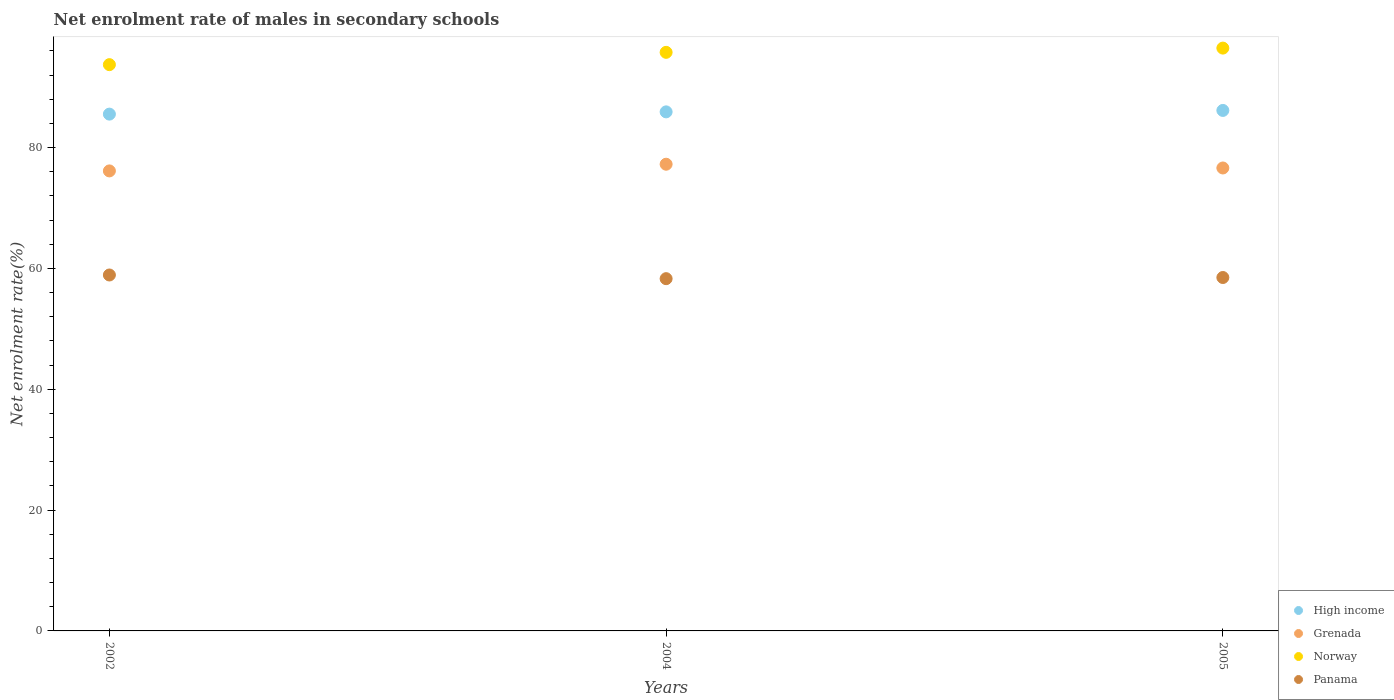How many different coloured dotlines are there?
Your response must be concise. 4. What is the net enrolment rate of males in secondary schools in Grenada in 2002?
Give a very brief answer. 76.14. Across all years, what is the maximum net enrolment rate of males in secondary schools in High income?
Your answer should be very brief. 86.15. Across all years, what is the minimum net enrolment rate of males in secondary schools in High income?
Make the answer very short. 85.54. In which year was the net enrolment rate of males in secondary schools in Panama minimum?
Provide a short and direct response. 2004. What is the total net enrolment rate of males in secondary schools in Grenada in the graph?
Give a very brief answer. 230. What is the difference between the net enrolment rate of males in secondary schools in Panama in 2002 and that in 2005?
Your response must be concise. 0.42. What is the difference between the net enrolment rate of males in secondary schools in Panama in 2002 and the net enrolment rate of males in secondary schools in Grenada in 2005?
Ensure brevity in your answer.  -17.71. What is the average net enrolment rate of males in secondary schools in High income per year?
Offer a very short reply. 85.86. In the year 2004, what is the difference between the net enrolment rate of males in secondary schools in Panama and net enrolment rate of males in secondary schools in High income?
Offer a terse response. -27.61. In how many years, is the net enrolment rate of males in secondary schools in Panama greater than 56 %?
Provide a short and direct response. 3. What is the ratio of the net enrolment rate of males in secondary schools in Norway in 2004 to that in 2005?
Offer a very short reply. 0.99. Is the net enrolment rate of males in secondary schools in Norway in 2002 less than that in 2005?
Provide a succinct answer. Yes. Is the difference between the net enrolment rate of males in secondary schools in Panama in 2004 and 2005 greater than the difference between the net enrolment rate of males in secondary schools in High income in 2004 and 2005?
Ensure brevity in your answer.  Yes. What is the difference between the highest and the second highest net enrolment rate of males in secondary schools in Grenada?
Your answer should be very brief. 0.62. What is the difference between the highest and the lowest net enrolment rate of males in secondary schools in Panama?
Your response must be concise. 0.61. In how many years, is the net enrolment rate of males in secondary schools in High income greater than the average net enrolment rate of males in secondary schools in High income taken over all years?
Make the answer very short. 2. Is it the case that in every year, the sum of the net enrolment rate of males in secondary schools in Panama and net enrolment rate of males in secondary schools in Grenada  is greater than the net enrolment rate of males in secondary schools in Norway?
Your response must be concise. Yes. Does the graph contain any zero values?
Provide a short and direct response. No. Where does the legend appear in the graph?
Keep it short and to the point. Bottom right. How many legend labels are there?
Your response must be concise. 4. What is the title of the graph?
Give a very brief answer. Net enrolment rate of males in secondary schools. Does "Arab World" appear as one of the legend labels in the graph?
Your answer should be very brief. No. What is the label or title of the X-axis?
Your answer should be very brief. Years. What is the label or title of the Y-axis?
Give a very brief answer. Net enrolment rate(%). What is the Net enrolment rate(%) of High income in 2002?
Ensure brevity in your answer.  85.54. What is the Net enrolment rate(%) of Grenada in 2002?
Your answer should be very brief. 76.14. What is the Net enrolment rate(%) of Norway in 2002?
Provide a short and direct response. 93.72. What is the Net enrolment rate(%) of Panama in 2002?
Your answer should be compact. 58.91. What is the Net enrolment rate(%) of High income in 2004?
Your answer should be compact. 85.91. What is the Net enrolment rate(%) in Grenada in 2004?
Make the answer very short. 77.24. What is the Net enrolment rate(%) of Norway in 2004?
Provide a succinct answer. 95.76. What is the Net enrolment rate(%) of Panama in 2004?
Your response must be concise. 58.3. What is the Net enrolment rate(%) of High income in 2005?
Your answer should be compact. 86.15. What is the Net enrolment rate(%) in Grenada in 2005?
Make the answer very short. 76.62. What is the Net enrolment rate(%) in Norway in 2005?
Your response must be concise. 96.46. What is the Net enrolment rate(%) in Panama in 2005?
Keep it short and to the point. 58.49. Across all years, what is the maximum Net enrolment rate(%) in High income?
Give a very brief answer. 86.15. Across all years, what is the maximum Net enrolment rate(%) in Grenada?
Ensure brevity in your answer.  77.24. Across all years, what is the maximum Net enrolment rate(%) of Norway?
Offer a very short reply. 96.46. Across all years, what is the maximum Net enrolment rate(%) of Panama?
Give a very brief answer. 58.91. Across all years, what is the minimum Net enrolment rate(%) in High income?
Offer a very short reply. 85.54. Across all years, what is the minimum Net enrolment rate(%) in Grenada?
Offer a terse response. 76.14. Across all years, what is the minimum Net enrolment rate(%) in Norway?
Give a very brief answer. 93.72. Across all years, what is the minimum Net enrolment rate(%) of Panama?
Offer a terse response. 58.3. What is the total Net enrolment rate(%) in High income in the graph?
Provide a short and direct response. 257.59. What is the total Net enrolment rate(%) of Grenada in the graph?
Ensure brevity in your answer.  230. What is the total Net enrolment rate(%) in Norway in the graph?
Offer a terse response. 285.95. What is the total Net enrolment rate(%) in Panama in the graph?
Ensure brevity in your answer.  175.71. What is the difference between the Net enrolment rate(%) of High income in 2002 and that in 2004?
Make the answer very short. -0.37. What is the difference between the Net enrolment rate(%) of Grenada in 2002 and that in 2004?
Provide a succinct answer. -1.11. What is the difference between the Net enrolment rate(%) in Norway in 2002 and that in 2004?
Your answer should be compact. -2.04. What is the difference between the Net enrolment rate(%) of Panama in 2002 and that in 2004?
Offer a very short reply. 0.61. What is the difference between the Net enrolment rate(%) of High income in 2002 and that in 2005?
Make the answer very short. -0.61. What is the difference between the Net enrolment rate(%) in Grenada in 2002 and that in 2005?
Your answer should be very brief. -0.48. What is the difference between the Net enrolment rate(%) of Norway in 2002 and that in 2005?
Offer a very short reply. -2.74. What is the difference between the Net enrolment rate(%) in Panama in 2002 and that in 2005?
Make the answer very short. 0.42. What is the difference between the Net enrolment rate(%) in High income in 2004 and that in 2005?
Offer a terse response. -0.24. What is the difference between the Net enrolment rate(%) in Grenada in 2004 and that in 2005?
Your answer should be compact. 0.62. What is the difference between the Net enrolment rate(%) of Norway in 2004 and that in 2005?
Keep it short and to the point. -0.7. What is the difference between the Net enrolment rate(%) in Panama in 2004 and that in 2005?
Your answer should be compact. -0.19. What is the difference between the Net enrolment rate(%) in High income in 2002 and the Net enrolment rate(%) in Grenada in 2004?
Provide a succinct answer. 8.29. What is the difference between the Net enrolment rate(%) in High income in 2002 and the Net enrolment rate(%) in Norway in 2004?
Offer a terse response. -10.23. What is the difference between the Net enrolment rate(%) in High income in 2002 and the Net enrolment rate(%) in Panama in 2004?
Offer a terse response. 27.23. What is the difference between the Net enrolment rate(%) in Grenada in 2002 and the Net enrolment rate(%) in Norway in 2004?
Keep it short and to the point. -19.62. What is the difference between the Net enrolment rate(%) of Grenada in 2002 and the Net enrolment rate(%) of Panama in 2004?
Your answer should be very brief. 17.83. What is the difference between the Net enrolment rate(%) in Norway in 2002 and the Net enrolment rate(%) in Panama in 2004?
Give a very brief answer. 35.42. What is the difference between the Net enrolment rate(%) in High income in 2002 and the Net enrolment rate(%) in Grenada in 2005?
Ensure brevity in your answer.  8.91. What is the difference between the Net enrolment rate(%) of High income in 2002 and the Net enrolment rate(%) of Norway in 2005?
Your response must be concise. -10.93. What is the difference between the Net enrolment rate(%) in High income in 2002 and the Net enrolment rate(%) in Panama in 2005?
Your answer should be very brief. 27.04. What is the difference between the Net enrolment rate(%) of Grenada in 2002 and the Net enrolment rate(%) of Norway in 2005?
Provide a succinct answer. -20.33. What is the difference between the Net enrolment rate(%) in Grenada in 2002 and the Net enrolment rate(%) in Panama in 2005?
Ensure brevity in your answer.  17.64. What is the difference between the Net enrolment rate(%) in Norway in 2002 and the Net enrolment rate(%) in Panama in 2005?
Your answer should be very brief. 35.23. What is the difference between the Net enrolment rate(%) in High income in 2004 and the Net enrolment rate(%) in Grenada in 2005?
Offer a terse response. 9.29. What is the difference between the Net enrolment rate(%) of High income in 2004 and the Net enrolment rate(%) of Norway in 2005?
Provide a short and direct response. -10.55. What is the difference between the Net enrolment rate(%) in High income in 2004 and the Net enrolment rate(%) in Panama in 2005?
Ensure brevity in your answer.  27.42. What is the difference between the Net enrolment rate(%) of Grenada in 2004 and the Net enrolment rate(%) of Norway in 2005?
Your response must be concise. -19.22. What is the difference between the Net enrolment rate(%) in Grenada in 2004 and the Net enrolment rate(%) in Panama in 2005?
Keep it short and to the point. 18.75. What is the difference between the Net enrolment rate(%) of Norway in 2004 and the Net enrolment rate(%) of Panama in 2005?
Make the answer very short. 37.27. What is the average Net enrolment rate(%) of High income per year?
Provide a short and direct response. 85.86. What is the average Net enrolment rate(%) in Grenada per year?
Make the answer very short. 76.67. What is the average Net enrolment rate(%) of Norway per year?
Offer a terse response. 95.32. What is the average Net enrolment rate(%) of Panama per year?
Provide a succinct answer. 58.57. In the year 2002, what is the difference between the Net enrolment rate(%) of High income and Net enrolment rate(%) of Grenada?
Keep it short and to the point. 9.4. In the year 2002, what is the difference between the Net enrolment rate(%) of High income and Net enrolment rate(%) of Norway?
Your answer should be compact. -8.19. In the year 2002, what is the difference between the Net enrolment rate(%) in High income and Net enrolment rate(%) in Panama?
Provide a succinct answer. 26.62. In the year 2002, what is the difference between the Net enrolment rate(%) in Grenada and Net enrolment rate(%) in Norway?
Ensure brevity in your answer.  -17.59. In the year 2002, what is the difference between the Net enrolment rate(%) of Grenada and Net enrolment rate(%) of Panama?
Your answer should be very brief. 17.23. In the year 2002, what is the difference between the Net enrolment rate(%) of Norway and Net enrolment rate(%) of Panama?
Provide a short and direct response. 34.81. In the year 2004, what is the difference between the Net enrolment rate(%) of High income and Net enrolment rate(%) of Grenada?
Offer a terse response. 8.67. In the year 2004, what is the difference between the Net enrolment rate(%) in High income and Net enrolment rate(%) in Norway?
Your answer should be compact. -9.85. In the year 2004, what is the difference between the Net enrolment rate(%) in High income and Net enrolment rate(%) in Panama?
Your answer should be compact. 27.61. In the year 2004, what is the difference between the Net enrolment rate(%) of Grenada and Net enrolment rate(%) of Norway?
Offer a terse response. -18.52. In the year 2004, what is the difference between the Net enrolment rate(%) in Grenada and Net enrolment rate(%) in Panama?
Ensure brevity in your answer.  18.94. In the year 2004, what is the difference between the Net enrolment rate(%) in Norway and Net enrolment rate(%) in Panama?
Keep it short and to the point. 37.46. In the year 2005, what is the difference between the Net enrolment rate(%) in High income and Net enrolment rate(%) in Grenada?
Your answer should be very brief. 9.52. In the year 2005, what is the difference between the Net enrolment rate(%) in High income and Net enrolment rate(%) in Norway?
Ensure brevity in your answer.  -10.32. In the year 2005, what is the difference between the Net enrolment rate(%) in High income and Net enrolment rate(%) in Panama?
Your response must be concise. 27.65. In the year 2005, what is the difference between the Net enrolment rate(%) of Grenada and Net enrolment rate(%) of Norway?
Your response must be concise. -19.84. In the year 2005, what is the difference between the Net enrolment rate(%) of Grenada and Net enrolment rate(%) of Panama?
Give a very brief answer. 18.13. In the year 2005, what is the difference between the Net enrolment rate(%) in Norway and Net enrolment rate(%) in Panama?
Offer a very short reply. 37.97. What is the ratio of the Net enrolment rate(%) of Grenada in 2002 to that in 2004?
Provide a succinct answer. 0.99. What is the ratio of the Net enrolment rate(%) of Norway in 2002 to that in 2004?
Give a very brief answer. 0.98. What is the ratio of the Net enrolment rate(%) in Panama in 2002 to that in 2004?
Offer a very short reply. 1.01. What is the ratio of the Net enrolment rate(%) in High income in 2002 to that in 2005?
Your answer should be compact. 0.99. What is the ratio of the Net enrolment rate(%) in Grenada in 2002 to that in 2005?
Ensure brevity in your answer.  0.99. What is the ratio of the Net enrolment rate(%) in Norway in 2002 to that in 2005?
Your response must be concise. 0.97. What is the ratio of the Net enrolment rate(%) of Panama in 2002 to that in 2005?
Your response must be concise. 1.01. What is the ratio of the Net enrolment rate(%) in Grenada in 2004 to that in 2005?
Ensure brevity in your answer.  1.01. What is the difference between the highest and the second highest Net enrolment rate(%) in High income?
Your answer should be compact. 0.24. What is the difference between the highest and the second highest Net enrolment rate(%) in Grenada?
Offer a terse response. 0.62. What is the difference between the highest and the second highest Net enrolment rate(%) in Norway?
Offer a terse response. 0.7. What is the difference between the highest and the second highest Net enrolment rate(%) in Panama?
Keep it short and to the point. 0.42. What is the difference between the highest and the lowest Net enrolment rate(%) of High income?
Your answer should be compact. 0.61. What is the difference between the highest and the lowest Net enrolment rate(%) of Grenada?
Provide a succinct answer. 1.11. What is the difference between the highest and the lowest Net enrolment rate(%) in Norway?
Your answer should be very brief. 2.74. What is the difference between the highest and the lowest Net enrolment rate(%) of Panama?
Provide a short and direct response. 0.61. 